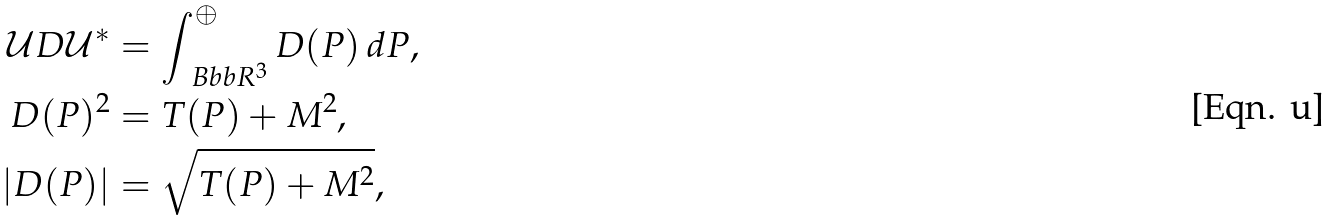<formula> <loc_0><loc_0><loc_500><loc_500>\mathcal { U } D \mathcal { U } ^ { * } & = \int ^ { \oplus } _ { \ B b b R ^ { 3 } } D ( P ) \, d P , \\ D ( P ) ^ { 2 } & = T ( P ) + M ^ { 2 } , \\ | D ( P ) | & = \sqrt { T ( P ) + M ^ { 2 } } ,</formula> 